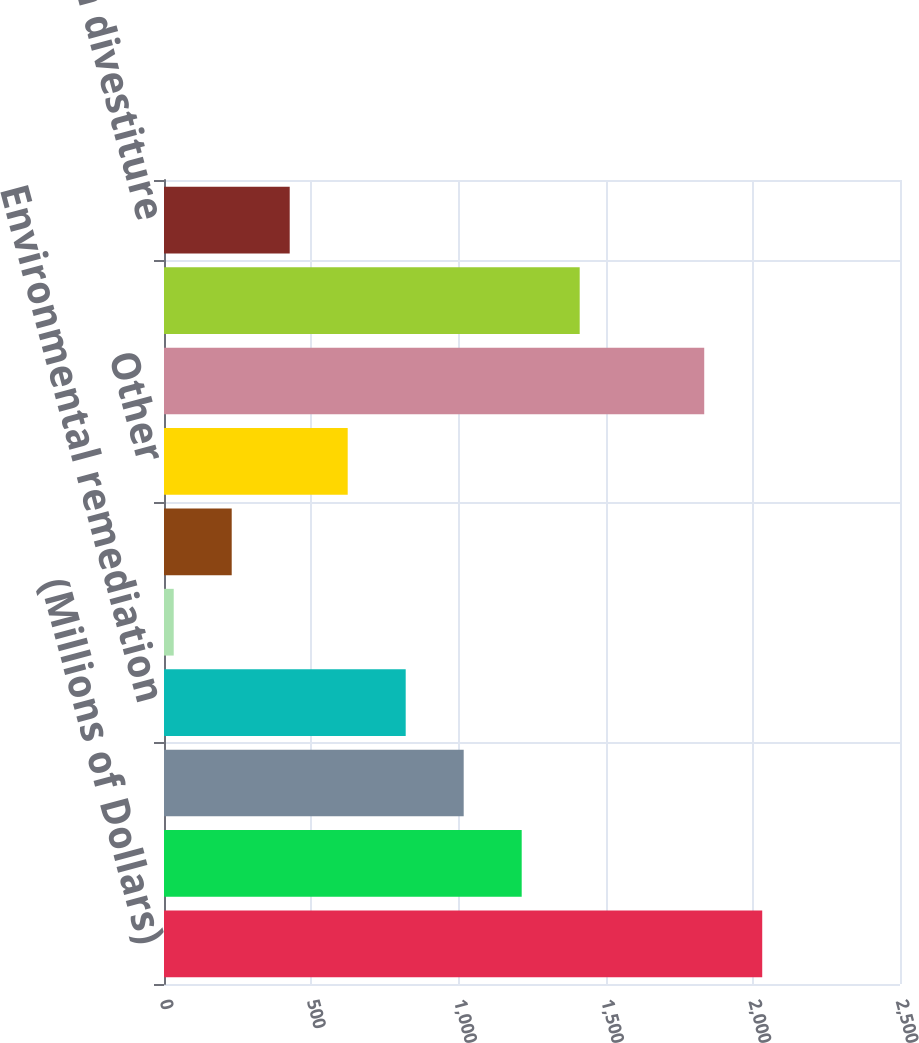<chart> <loc_0><loc_0><loc_500><loc_500><bar_chart><fcel>(Millions of Dollars)<fcel>Future federal income tax<fcel>Recoverable energy costs<fcel>Environmental remediation<fcel>Retirement program costs<fcel>Asbestos-related costs<fcel>Other<fcel>Total Regulatory Assets<fcel>Allowance for cost of removal<fcel>Gain on divestiture<nl><fcel>2032<fcel>1215<fcel>1018<fcel>821<fcel>33<fcel>230<fcel>624<fcel>1835<fcel>1412<fcel>427<nl></chart> 